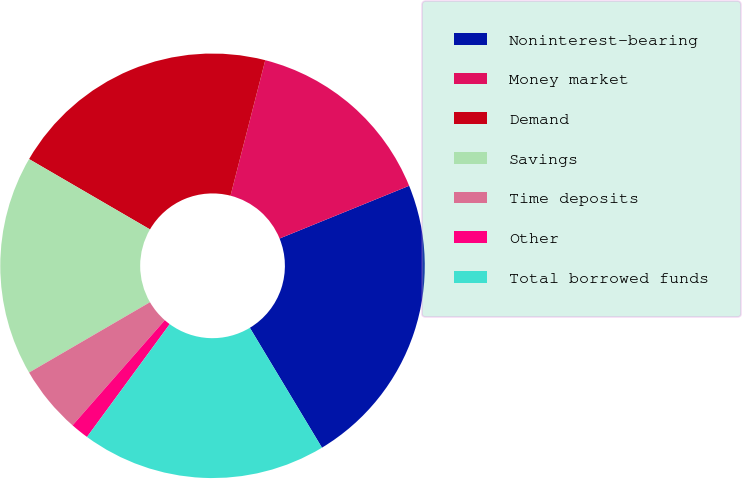<chart> <loc_0><loc_0><loc_500><loc_500><pie_chart><fcel>Noninterest-bearing<fcel>Money market<fcel>Demand<fcel>Savings<fcel>Time deposits<fcel>Other<fcel>Total borrowed funds<nl><fcel>22.53%<fcel>14.85%<fcel>20.61%<fcel>16.77%<fcel>5.15%<fcel>1.39%<fcel>18.69%<nl></chart> 